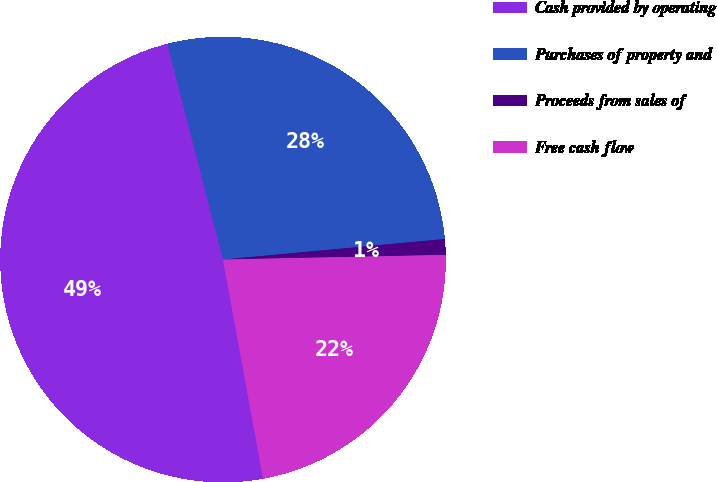<chart> <loc_0><loc_0><loc_500><loc_500><pie_chart><fcel>Cash provided by operating<fcel>Purchases of property and<fcel>Proceeds from sales of<fcel>Free cash flow<nl><fcel>48.86%<fcel>27.55%<fcel>1.14%<fcel>22.45%<nl></chart> 